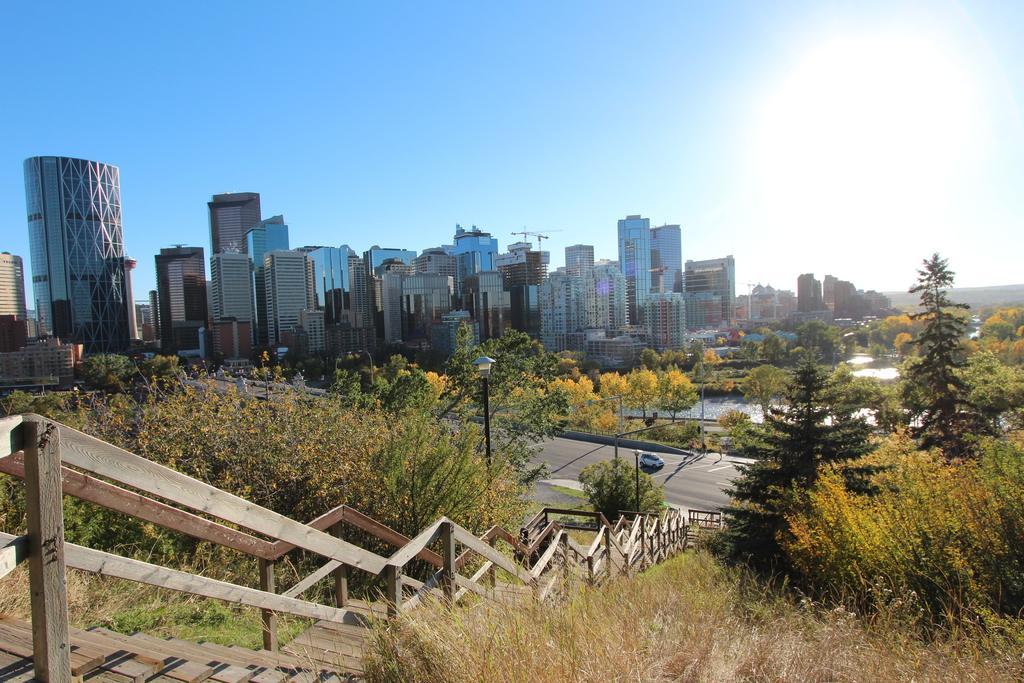Can you describe this image briefly? In this image we can see there are stairs and fence. And there are buildings, trees, light poles and the sky. There is a vehicle on the road. 